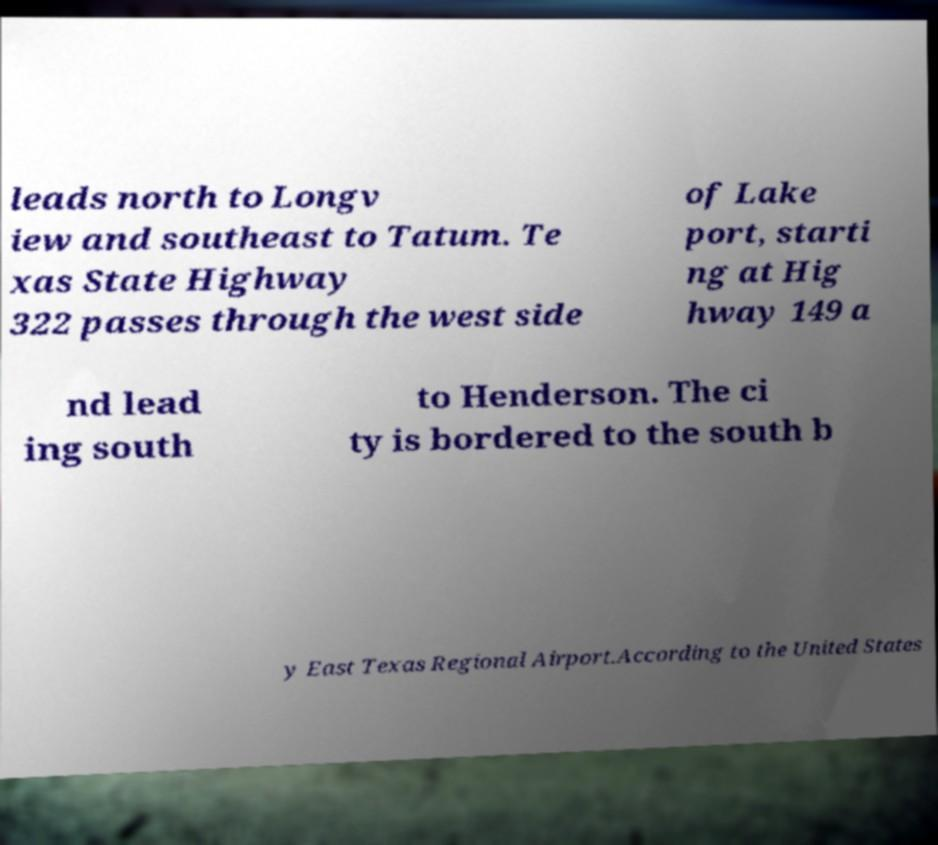Please read and relay the text visible in this image. What does it say? leads north to Longv iew and southeast to Tatum. Te xas State Highway 322 passes through the west side of Lake port, starti ng at Hig hway 149 a nd lead ing south to Henderson. The ci ty is bordered to the south b y East Texas Regional Airport.According to the United States 